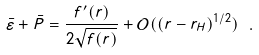Convert formula to latex. <formula><loc_0><loc_0><loc_500><loc_500>\bar { \varepsilon } + \bar { P } = \frac { f ^ { \prime } ( r ) } { 2 \sqrt { f ( r ) } } + \mathcal { O } ( ( r - r _ { H } ) ^ { 1 / 2 } ) \ .</formula> 